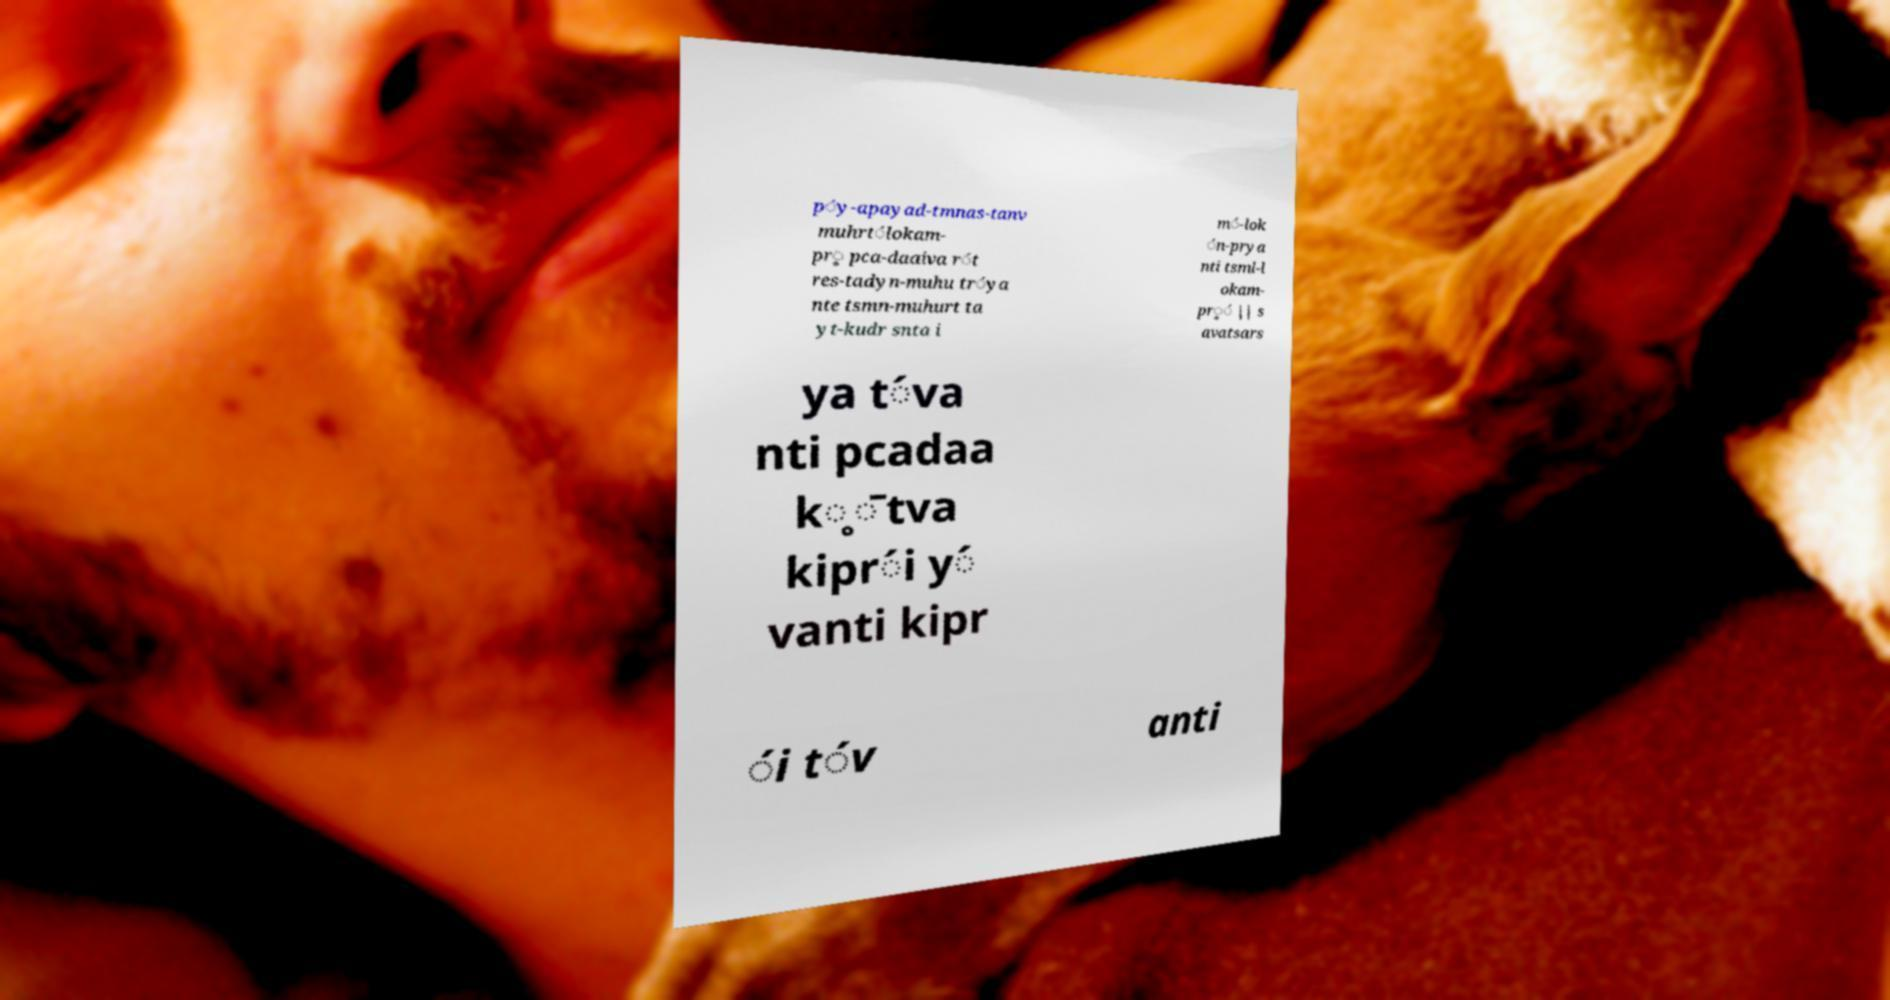For documentation purposes, I need the text within this image transcribed. Could you provide that? ṕy-apayad-tmnas-tanv muhrt́lokam- pr̥ pca-daaiva ŕt res-tadyn-muhu tŕya nte tsmn-muhurt ta yt-kudr snta i ḿ-lok ́n-prya nti tsml-l okam- pŕ̥ || s avatsars ya t́va nti pcadaa k̥̄tva kipŕi ý vanti kipr ́i t́v anti 